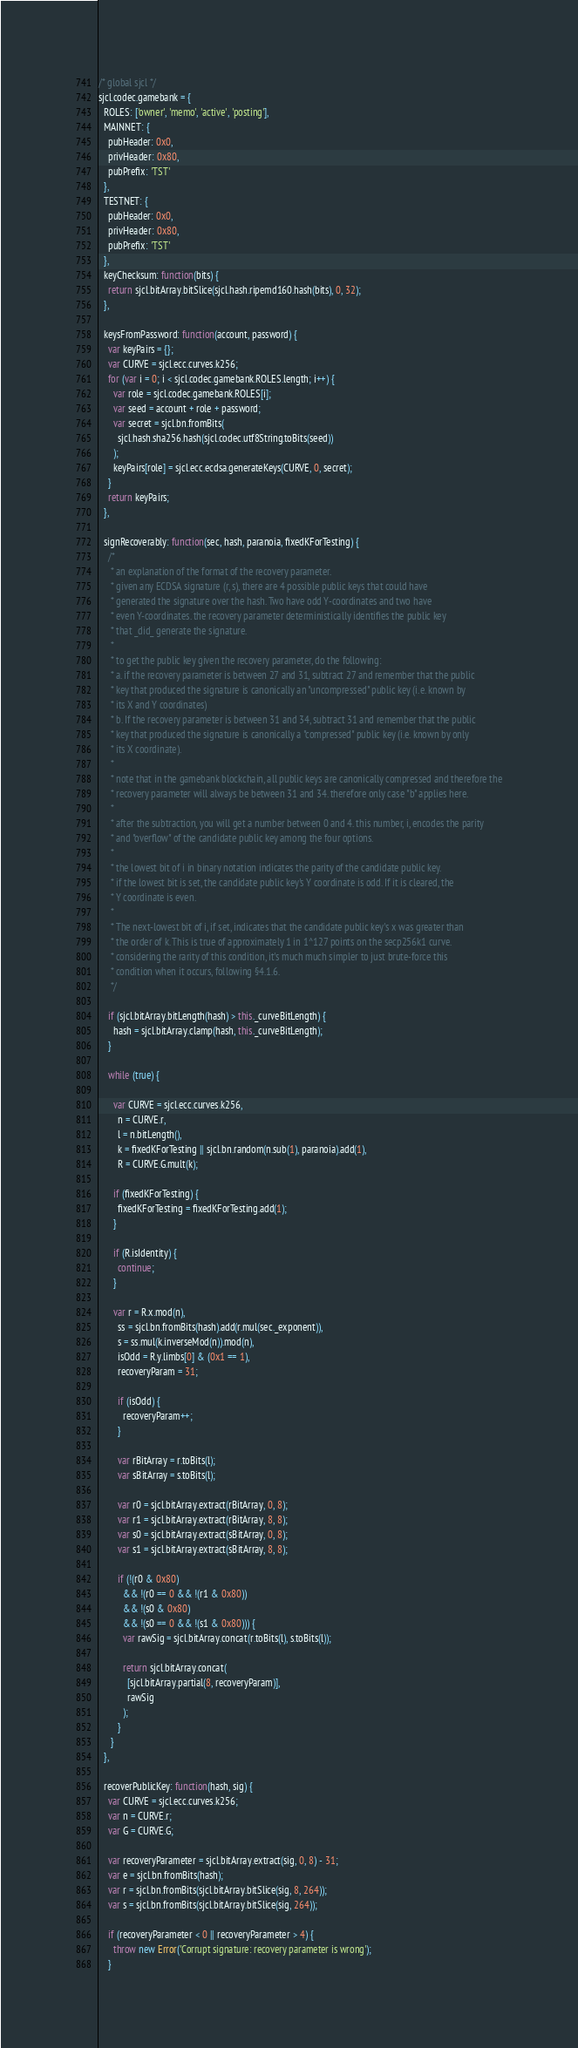Convert code to text. <code><loc_0><loc_0><loc_500><loc_500><_JavaScript_>/* global sjcl */
sjcl.codec.gamebank = {
  ROLES: ['owner', 'memo', 'active', 'posting'],
  MAINNET: {
    pubHeader: 0x0,
    privHeader: 0x80,
    pubPrefix: 'TST'
  },
  TESTNET: {
    pubHeader: 0x0,
    privHeader: 0x80,
    pubPrefix: 'TST'
  },
  keyChecksum: function(bits) {
    return sjcl.bitArray.bitSlice(sjcl.hash.ripemd160.hash(bits), 0, 32);
  },

  keysFromPassword: function(account, password) {
    var keyPairs = {};
    var CURVE = sjcl.ecc.curves.k256;
    for (var i = 0; i < sjcl.codec.gamebank.ROLES.length; i++) {
      var role = sjcl.codec.gamebank.ROLES[i];
      var seed = account + role + password;
      var secret = sjcl.bn.fromBits(
        sjcl.hash.sha256.hash(sjcl.codec.utf8String.toBits(seed))
      );
      keyPairs[role] = sjcl.ecc.ecdsa.generateKeys(CURVE, 0, secret);
    }
    return keyPairs;
  },

  signRecoverably: function(sec, hash, paranoia, fixedKForTesting) {
    /*
     * an explanation of the format of the recovery parameter.
     * given any ECDSA signature (r, s), there are 4 possible public keys that could have
     * generated the signature over the hash. Two have odd Y-coordinates and two have
     * even Y-coordinates. the recovery parameter deterministically identifies the public key
     * that _did_ generate the signature.
     *
     * to get the public key given the recovery parameter, do the following:
     * a. if the recovery parameter is between 27 and 31, subtract 27 and remember that the public
     * key that produced the signature is canonically an "uncompressed" public key (i.e. known by
     * its X and Y coordinates)
     * b. If the recovery parameter is between 31 and 34, subtract 31 and remember that the public
     * key that produced the signature is canonically a "compressed" public key (i.e. known by only
     * its X coordinate).
     *
     * note that in the gamebank blockchain, all public keys are canonically compressed and therefore the
     * recovery parameter will always be between 31 and 34. therefore only case "b" applies here.
     *
     * after the subtraction, you will get a number between 0 and 4. this number, i, encodes the parity
     * and "overflow" of the candidate public key among the four options.
     *
     * the lowest bit of i in binary notation indicates the parity of the candidate public key.
     * if the lowest bit is set, the candidate public key's Y coordinate is odd. If it is cleared, the
     * Y coordinate is even.
     *
     * The next-lowest bit of i, if set, indicates that the candidate public key's x was greater than
     * the order of k. This is true of approximately 1 in 1^127 points on the secp256k1 curve.
     * considering the rarity of this condition, it's much much simpler to just brute-force this
     * condition when it occurs, following §4.1.6.
     */

    if (sjcl.bitArray.bitLength(hash) > this._curveBitLength) {
      hash = sjcl.bitArray.clamp(hash, this._curveBitLength);
    }

    while (true) {

      var CURVE = sjcl.ecc.curves.k256,
        n = CURVE.r,
        l = n.bitLength(),
        k = fixedKForTesting || sjcl.bn.random(n.sub(1), paranoia).add(1),
        R = CURVE.G.mult(k);

      if (fixedKForTesting) {
        fixedKForTesting = fixedKForTesting.add(1);
      }
      
      if (R.isIdentity) {
        continue;
      }

      var r = R.x.mod(n),
        ss = sjcl.bn.fromBits(hash).add(r.mul(sec._exponent)),
        s = ss.mul(k.inverseMod(n)).mod(n),
        isOdd = R.y.limbs[0] & (0x1 == 1),
        recoveryParam = 31;

        if (isOdd) {
          recoveryParam++;
        }
   
        var rBitArray = r.toBits(l);
        var sBitArray = s.toBits(l);

        var r0 = sjcl.bitArray.extract(rBitArray, 0, 8);
        var r1 = sjcl.bitArray.extract(rBitArray, 8, 8);
        var s0 = sjcl.bitArray.extract(sBitArray, 0, 8);
        var s1 = sjcl.bitArray.extract(sBitArray, 8, 8);
            
        if (!(r0 & 0x80)
          && !(r0 == 0 && !(r1 & 0x80))
          && !(s0 & 0x80)
          && !(s0 == 0 && !(s1 & 0x80))) {
          var rawSig = sjcl.bitArray.concat(r.toBits(l), s.toBits(l));
      
          return sjcl.bitArray.concat(
            [sjcl.bitArray.partial(8, recoveryParam)],
            rawSig
          );
        }
     }
  },

  recoverPublicKey: function(hash, sig) {
    var CURVE = sjcl.ecc.curves.k256;
    var n = CURVE.r;
    var G = CURVE.G;

    var recoveryParameter = sjcl.bitArray.extract(sig, 0, 8) - 31;
    var e = sjcl.bn.fromBits(hash);
    var r = sjcl.bn.fromBits(sjcl.bitArray.bitSlice(sig, 8, 264));
    var s = sjcl.bn.fromBits(sjcl.bitArray.bitSlice(sig, 264));

    if (recoveryParameter < 0 || recoveryParameter > 4) {
      throw new Error('Corrupt signature: recovery parameter is wrong');
    }
</code> 